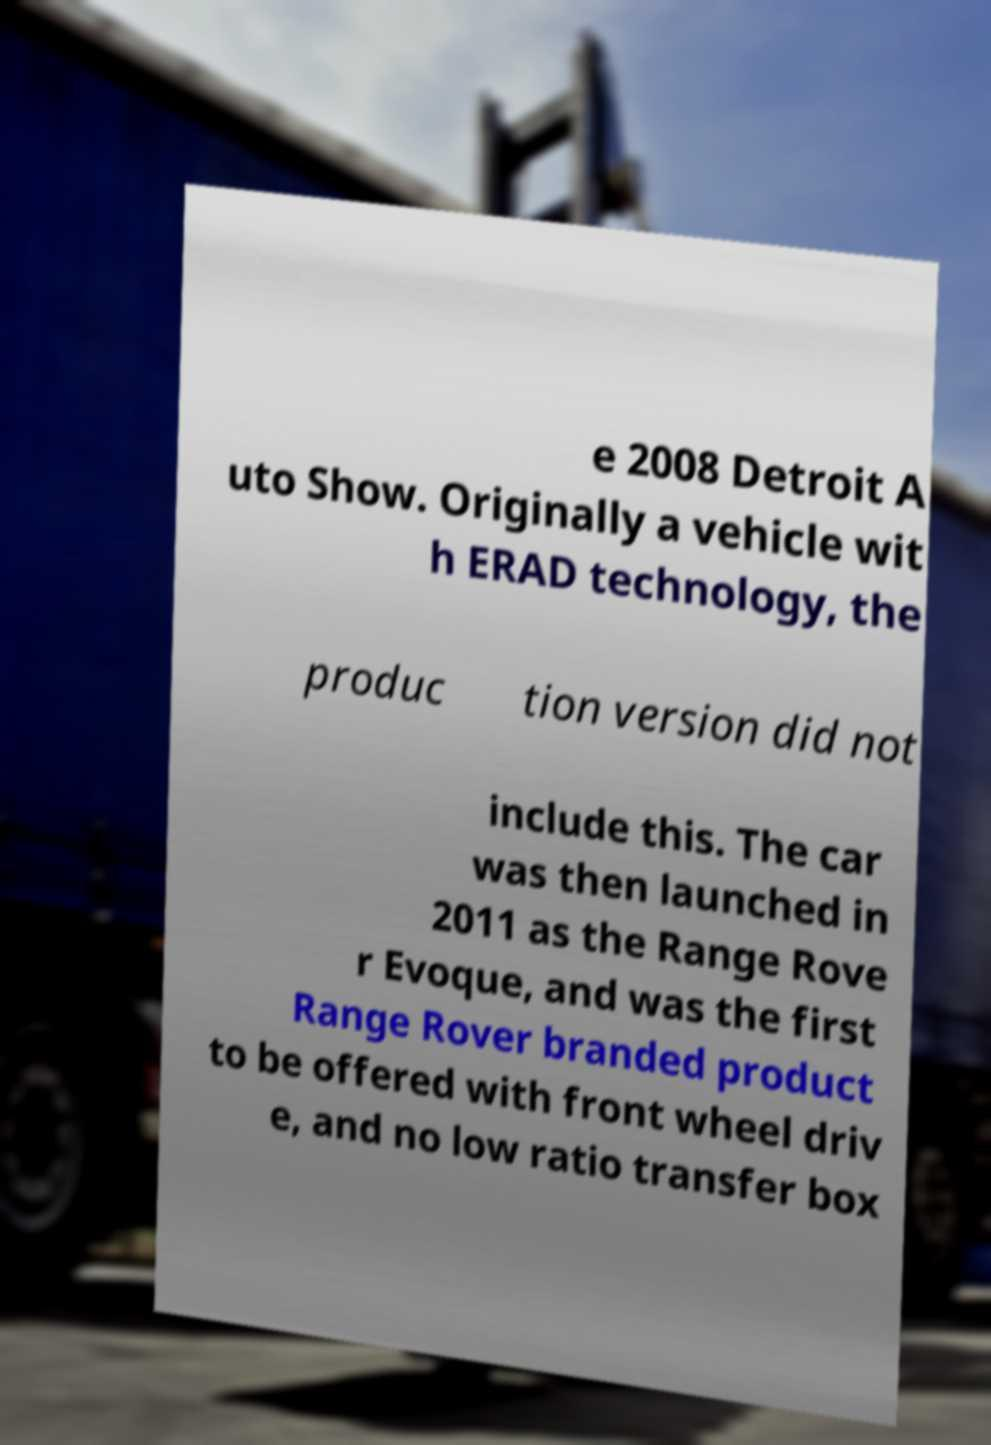There's text embedded in this image that I need extracted. Can you transcribe it verbatim? e 2008 Detroit A uto Show. Originally a vehicle wit h ERAD technology, the produc tion version did not include this. The car was then launched in 2011 as the Range Rove r Evoque, and was the first Range Rover branded product to be offered with front wheel driv e, and no low ratio transfer box 